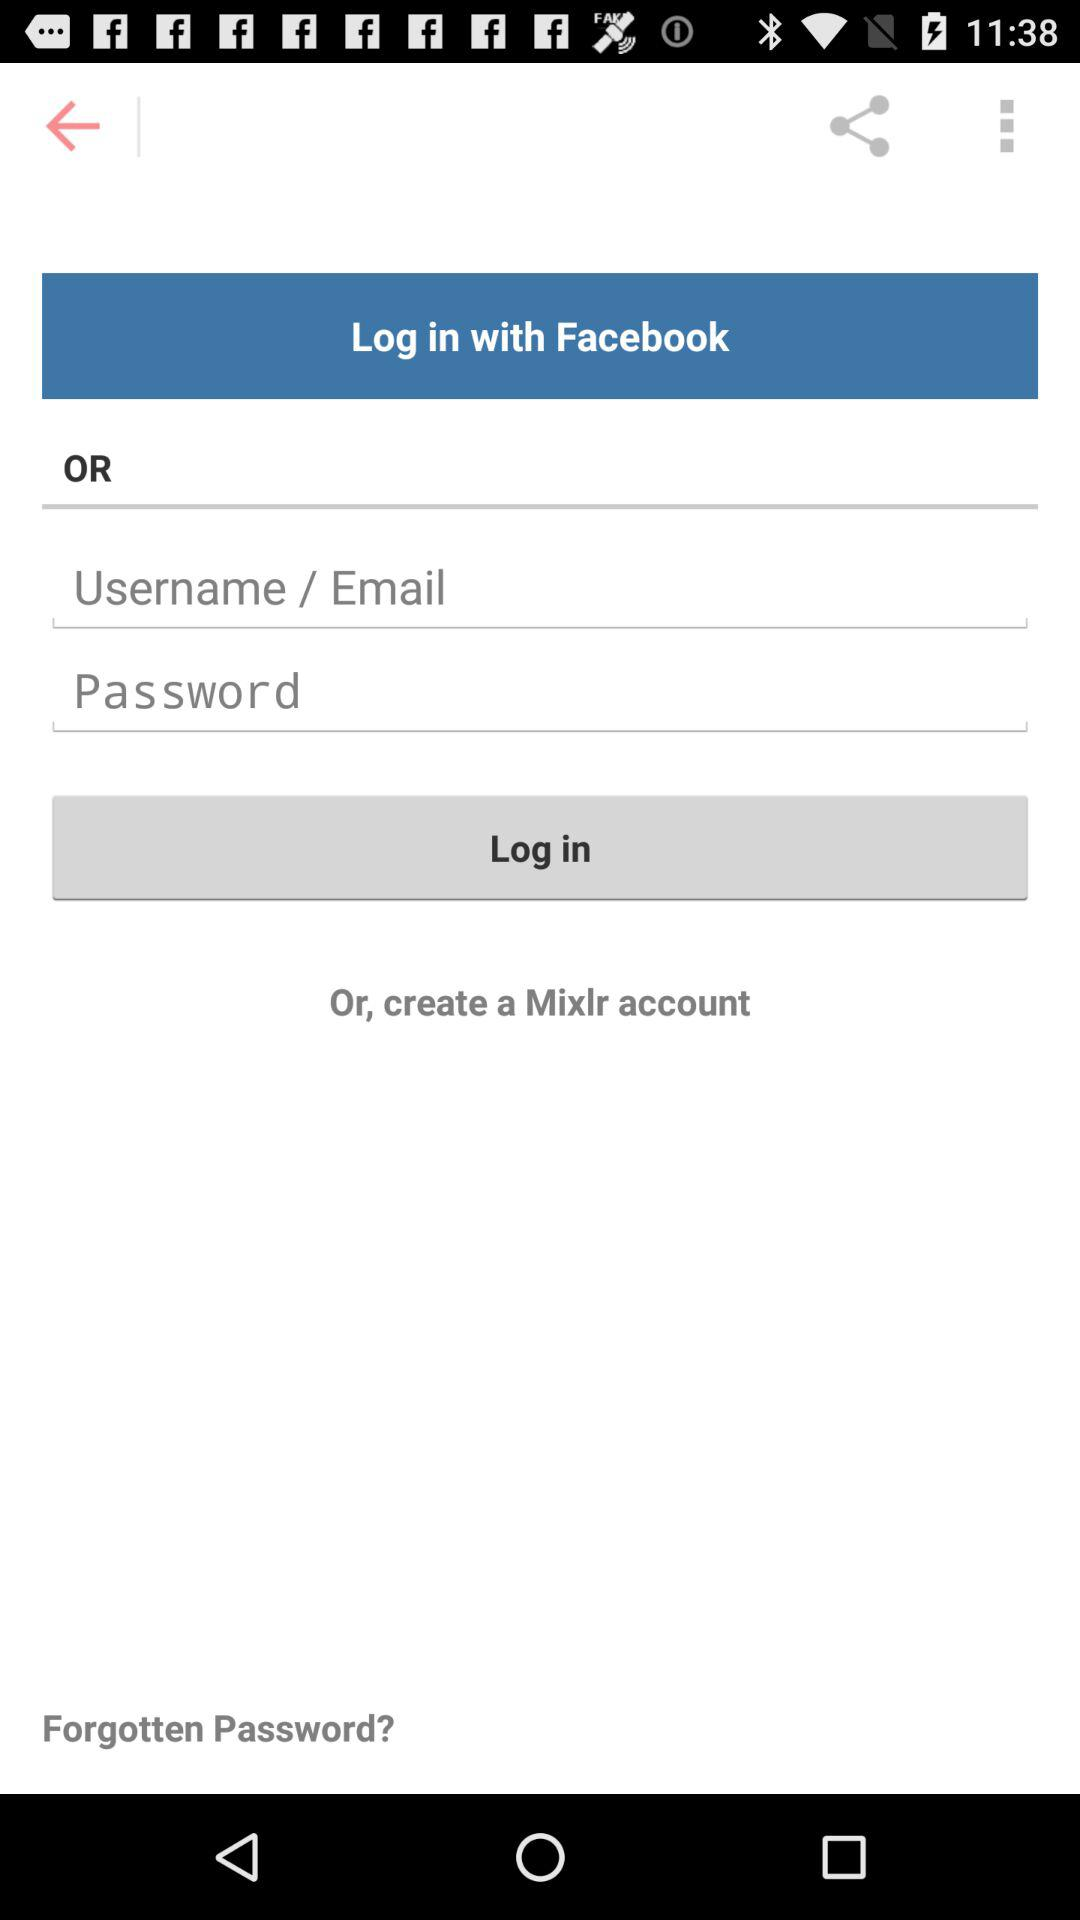How can we log in? You can either log in with "Facebook" or "Username / Email" and "Password". 